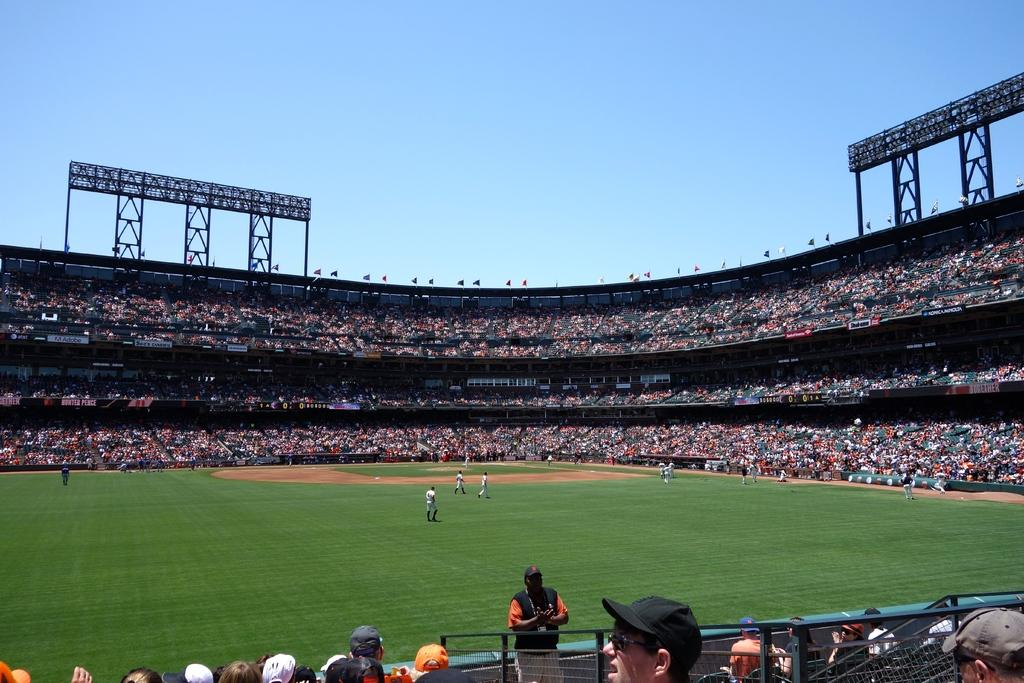What type of structure is shown in the image? The image depicts a stadium. Can you describe the people in the stadium? There are people on the ground in the stadium, and there are many people in the stadium. What can be seen at the top of the stadium? There are poles visible at the top of the stadium. What is visible at the top of the image? The sky is visible at the top of the image. What type of vest is being worn by the marble in the image? There is no vest or marble present in the image; it features a stadium with people and poles. 